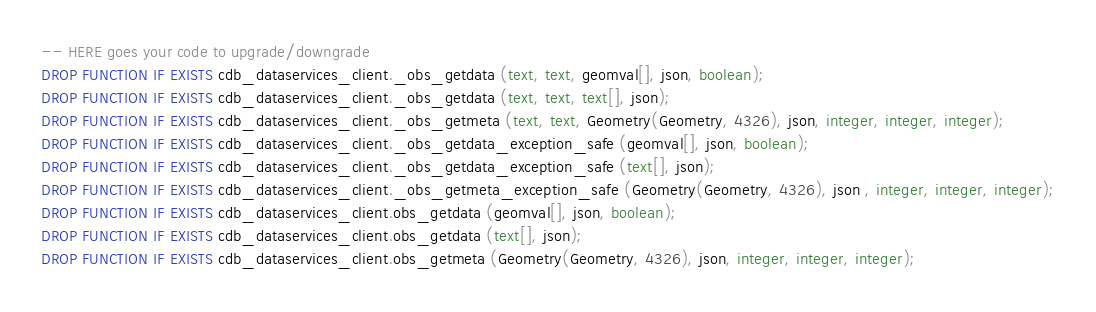<code> <loc_0><loc_0><loc_500><loc_500><_SQL_>
-- HERE goes your code to upgrade/downgrade
DROP FUNCTION IF EXISTS cdb_dataservices_client._obs_getdata (text, text, geomval[], json, boolean);
DROP FUNCTION IF EXISTS cdb_dataservices_client._obs_getdata (text, text, text[], json);
DROP FUNCTION IF EXISTS cdb_dataservices_client._obs_getmeta (text, text, Geometry(Geometry, 4326), json, integer, integer, integer);
DROP FUNCTION IF EXISTS cdb_dataservices_client._obs_getdata_exception_safe (geomval[], json, boolean);
DROP FUNCTION IF EXISTS cdb_dataservices_client._obs_getdata_exception_safe (text[], json);
DROP FUNCTION IF EXISTS cdb_dataservices_client._obs_getmeta_exception_safe (Geometry(Geometry, 4326), json , integer, integer, integer);
DROP FUNCTION IF EXISTS cdb_dataservices_client.obs_getdata (geomval[], json, boolean);
DROP FUNCTION IF EXISTS cdb_dataservices_client.obs_getdata (text[], json);
DROP FUNCTION IF EXISTS cdb_dataservices_client.obs_getmeta (Geometry(Geometry, 4326), json, integer, integer, integer);
</code> 